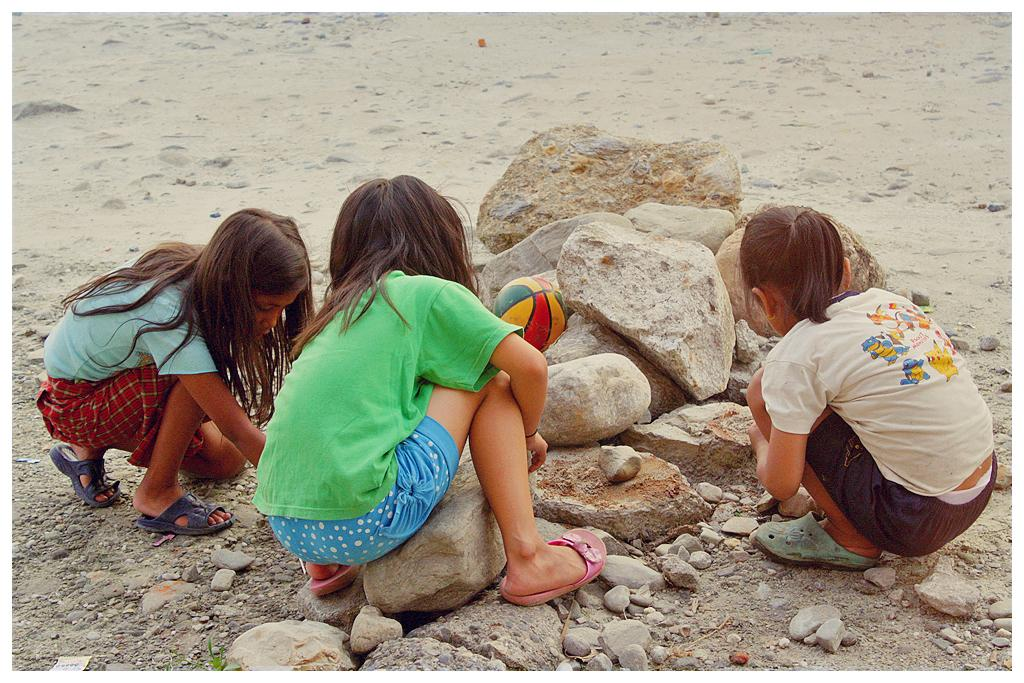What is on the ground in the image? There are rocks on the ground in the image. How many girls are in the image? There are three girls in the image. What are the girls doing in the image? The girls are playing with stones. What else can be seen in the image besides the girls and rocks? There is a ball visible in the image. What type of drug is the beginner using in the image? There is no drug or beginner present in the image. How many legs can be seen on the girls in the image? The image does not show the girls' legs, so it is impossible to determine the number of legs visible. 